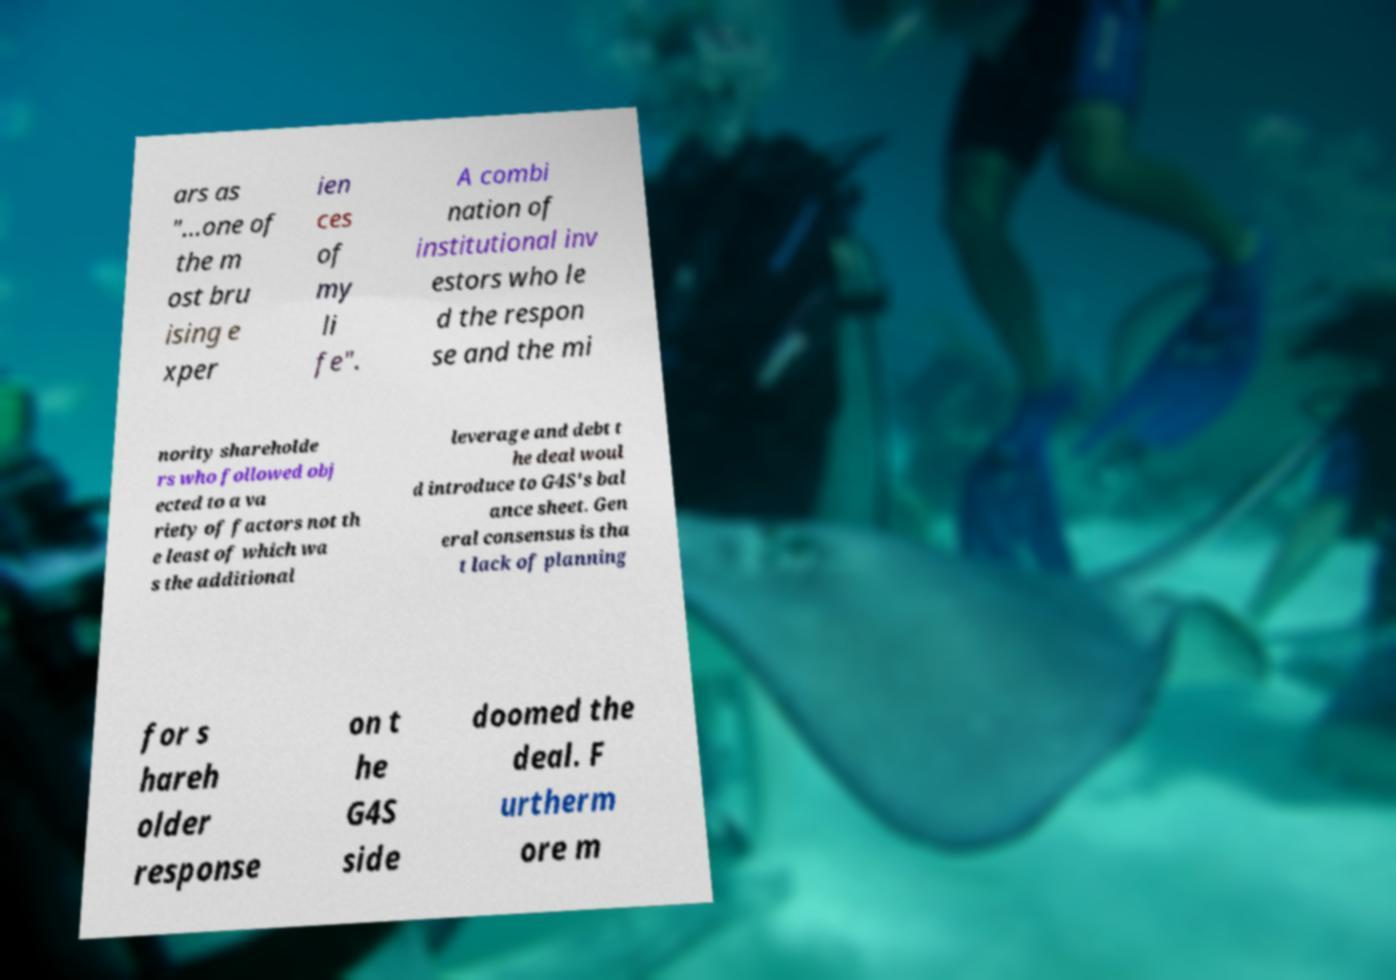Please identify and transcribe the text found in this image. ars as "...one of the m ost bru ising e xper ien ces of my li fe". A combi nation of institutional inv estors who le d the respon se and the mi nority shareholde rs who followed obj ected to a va riety of factors not th e least of which wa s the additional leverage and debt t he deal woul d introduce to G4S's bal ance sheet. Gen eral consensus is tha t lack of planning for s hareh older response on t he G4S side doomed the deal. F urtherm ore m 